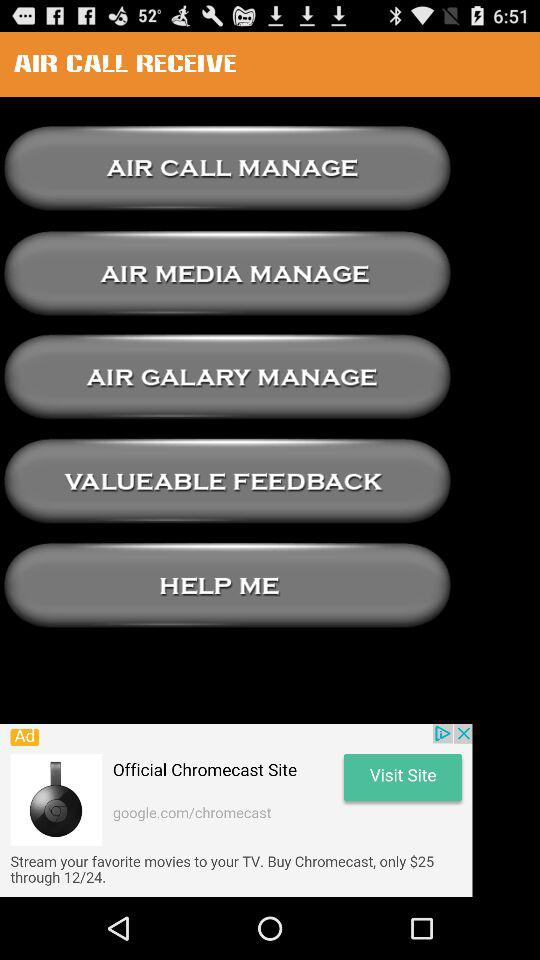How many dollars is the Chromecast on sale for?
Answer the question using a single word or phrase. $25 